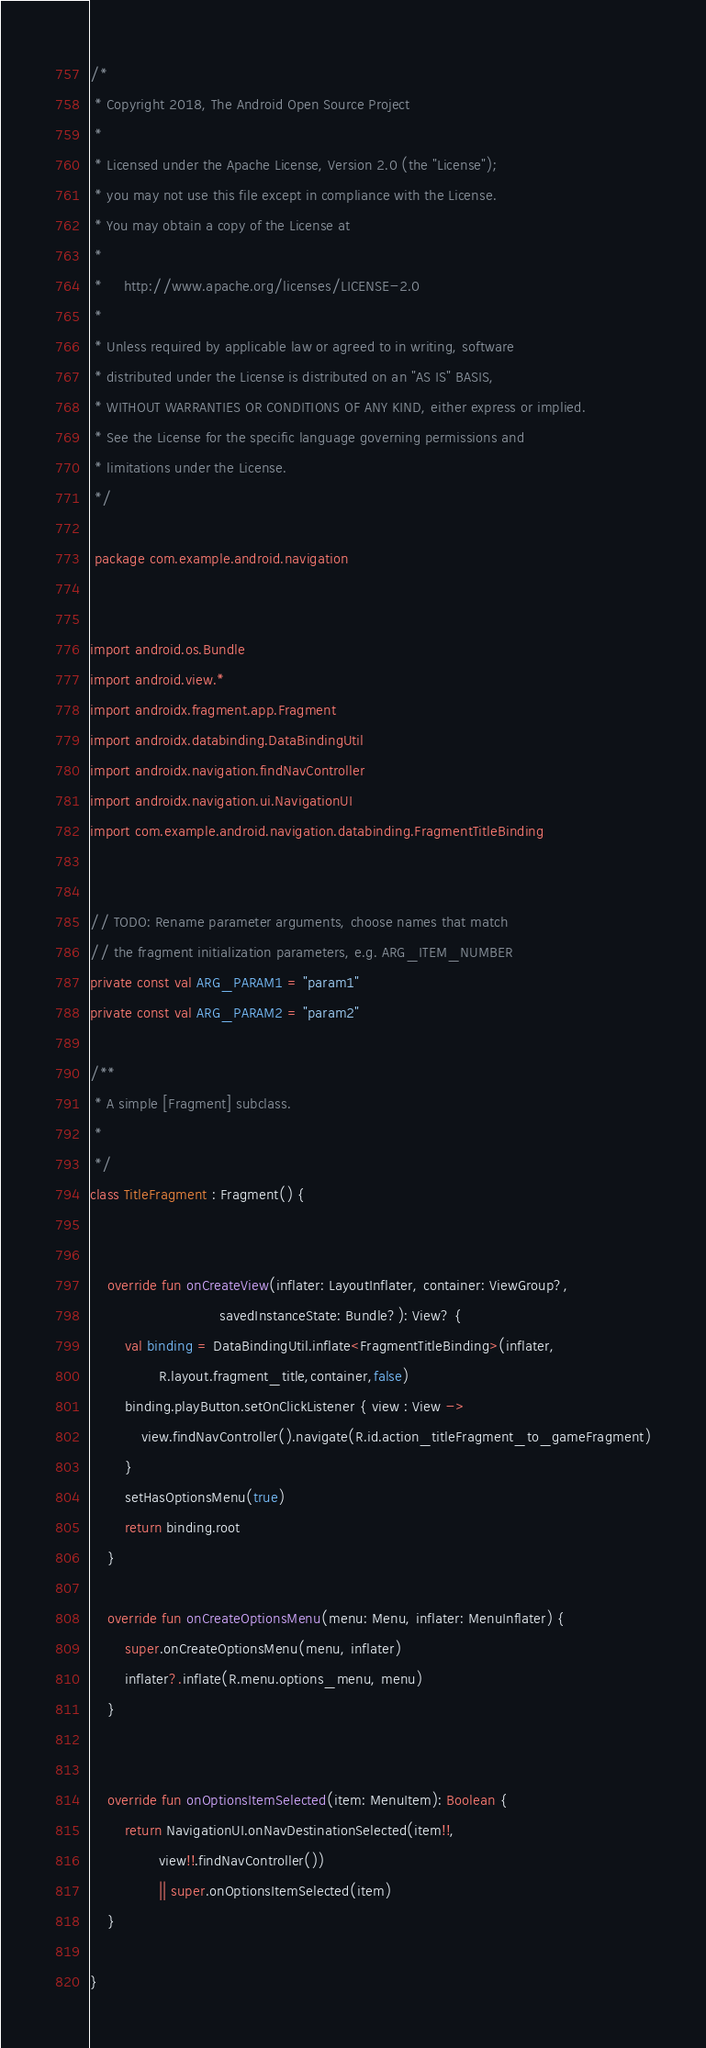Convert code to text. <code><loc_0><loc_0><loc_500><loc_500><_Kotlin_>/*
 * Copyright 2018, The Android Open Source Project
 *
 * Licensed under the Apache License, Version 2.0 (the "License");
 * you may not use this file except in compliance with the License.
 * You may obtain a copy of the License at
 *
 *     http://www.apache.org/licenses/LICENSE-2.0
 *
 * Unless required by applicable law or agreed to in writing, software
 * distributed under the License is distributed on an "AS IS" BASIS,
 * WITHOUT WARRANTIES OR CONDITIONS OF ANY KIND, either express or implied.
 * See the License for the specific language governing permissions and
 * limitations under the License.
 */

 package com.example.android.navigation


import android.os.Bundle
import android.view.*
import androidx.fragment.app.Fragment
import androidx.databinding.DataBindingUtil
import androidx.navigation.findNavController
import androidx.navigation.ui.NavigationUI
import com.example.android.navigation.databinding.FragmentTitleBinding


// TODO: Rename parameter arguments, choose names that match
// the fragment initialization parameters, e.g. ARG_ITEM_NUMBER
private const val ARG_PARAM1 = "param1"
private const val ARG_PARAM2 = "param2"

/**
 * A simple [Fragment] subclass.
 *
 */
class TitleFragment : Fragment() {


    override fun onCreateView(inflater: LayoutInflater, container: ViewGroup?,
                              savedInstanceState: Bundle?): View? {
        val binding = DataBindingUtil.inflate<FragmentTitleBinding>(inflater,
                R.layout.fragment_title,container,false)
        binding.playButton.setOnClickListener { view : View ->
            view.findNavController().navigate(R.id.action_titleFragment_to_gameFragment)
        }
        setHasOptionsMenu(true)
        return binding.root
    }

    override fun onCreateOptionsMenu(menu: Menu, inflater: MenuInflater) {
        super.onCreateOptionsMenu(menu, inflater)
        inflater?.inflate(R.menu.options_menu, menu)
    }


    override fun onOptionsItemSelected(item: MenuItem): Boolean {
        return NavigationUI.onNavDestinationSelected(item!!,
                view!!.findNavController())
                || super.onOptionsItemSelected(item)
    }

}
</code> 